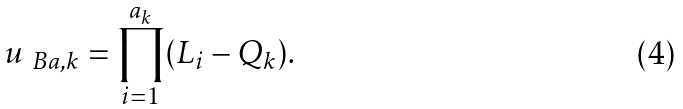Convert formula to latex. <formula><loc_0><loc_0><loc_500><loc_500>u _ { \ B a , k } = \prod _ { i = 1 } ^ { a _ { k } } ( L _ { i } - Q _ { k } ) .</formula> 